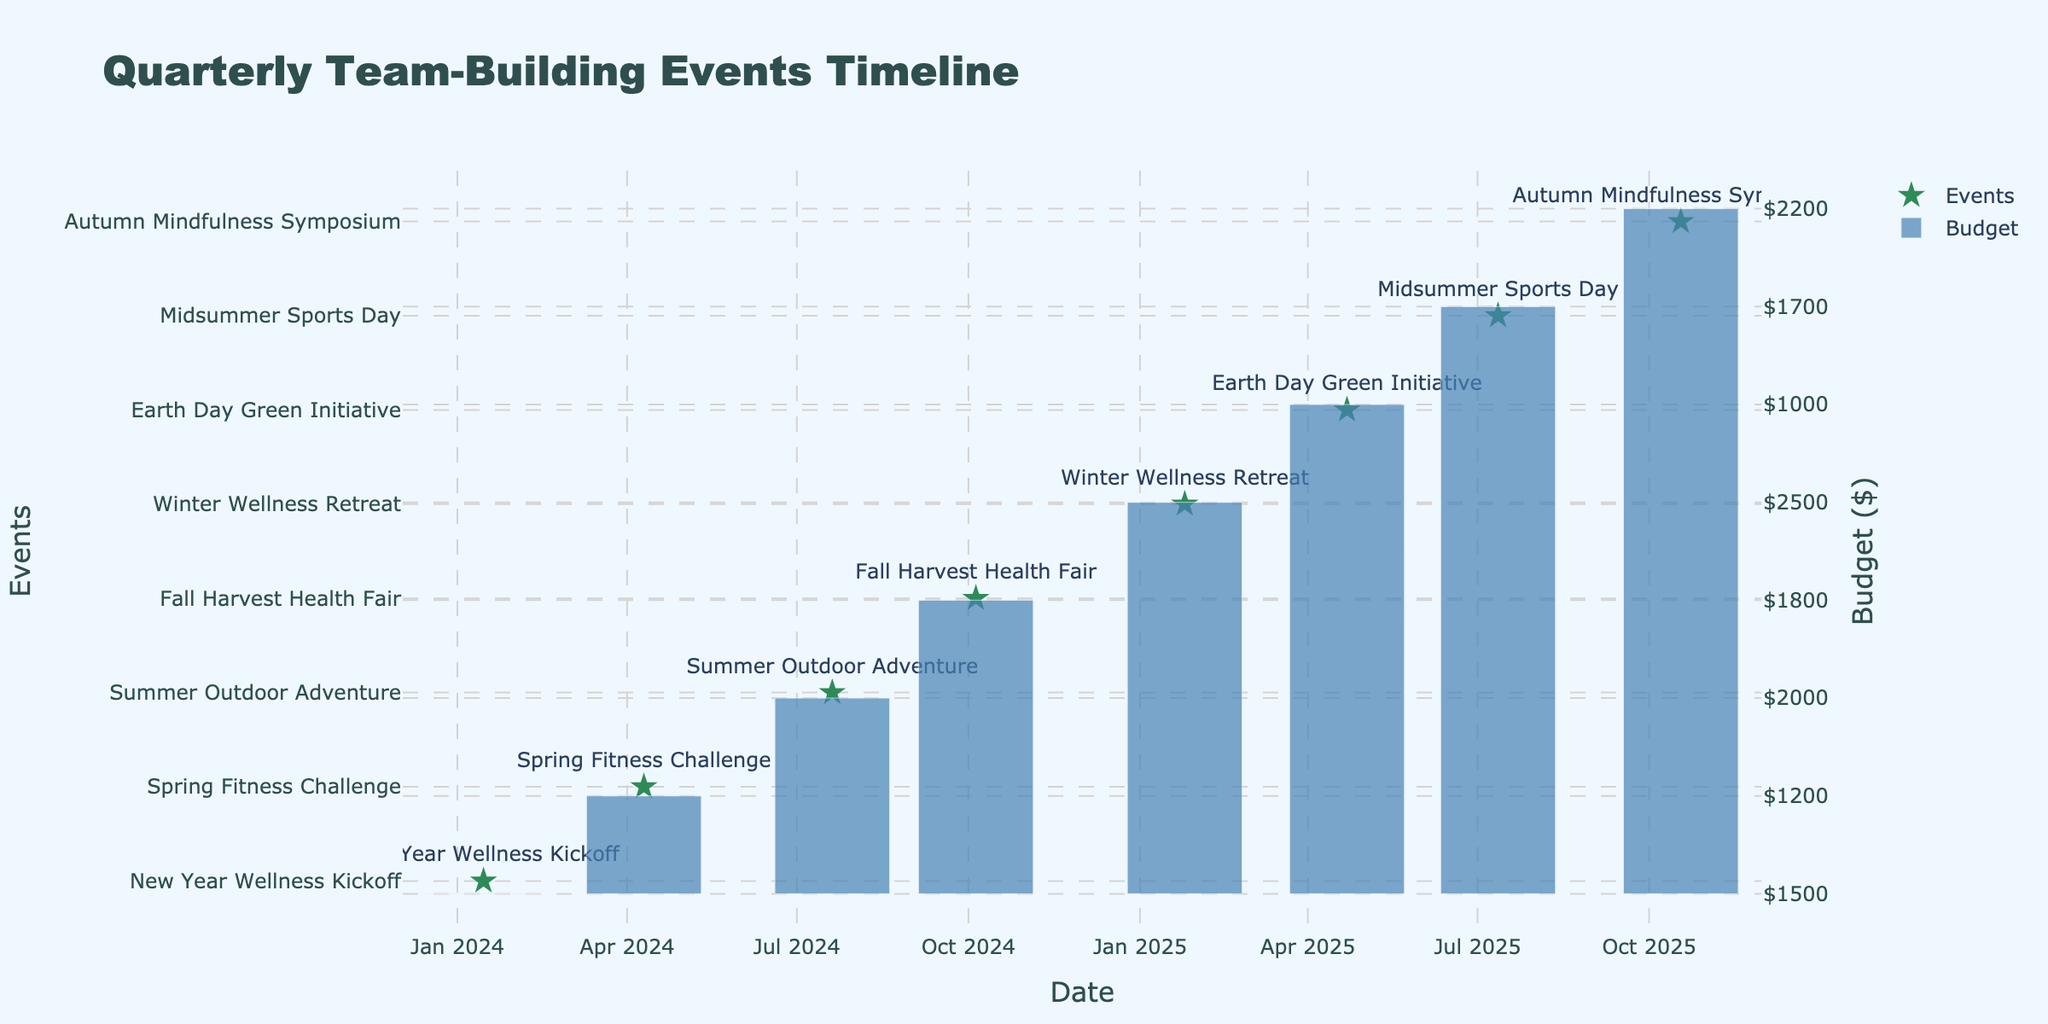What is the budget for the Fall Harvest Health Fair? The budget for the Fall Harvest Health Fair is listed in the Budget column next to the event name. It is $1800.
Answer: $1800 Which event has the highest expected participation rate? The Fall Harvest Health Fair has an expected participation rate of 100%, which is higher than all other events listed.
Answer: 100% What is the total budget allocated for events in the first half of the fiscal year? The events in the first half are: New Year Wellness Kickoff ($1500), Spring Fitness Challenge ($1200), and Summer Outdoor Adventure ($2000). Summing these amounts gives $1500 + $1200 + $2000 = $4700.
Answer: $4700 Does the Winter Wellness Retreat have a budget higher than $2000? The budget for the Winter Wellness Retreat is $2500, which is indeed higher than $2000.
Answer: Yes What is the average expected participation rate across all events? The expected participation rates are 95%, 90%, 85%, 100%, 80%, 95%, 85%, and 90%. To find the average, we sum these: (95 + 90 + 85 + 100 + 80 + 95 + 85 + 90) = 720. There are 8 events, so the average is 720 / 8 = 90.
Answer: 90 Which event is scheduled last in the timeline? The event that is scheduled last in the timeline is the Winter Wellness Retreat, which takes place on January 25, 2025. It appears to be the most recent date listed.
Answer: Winter Wellness Retreat How many events are scheduled to take place outdoors? The events taking place outdoors according to the location are the New Year Wellness Kickoff (Central Park), Summer Outdoor Adventure (Bear Mountain State Park), and Earth Day Green Initiative (City Botanic Gardens). That totals three events.
Answer: 3 What is the date of the Spring Fitness Challenge? The date of the Spring Fitness Challenge is specified in the Date column, which is April 10, 2024.
Answer: April 10, 2024 